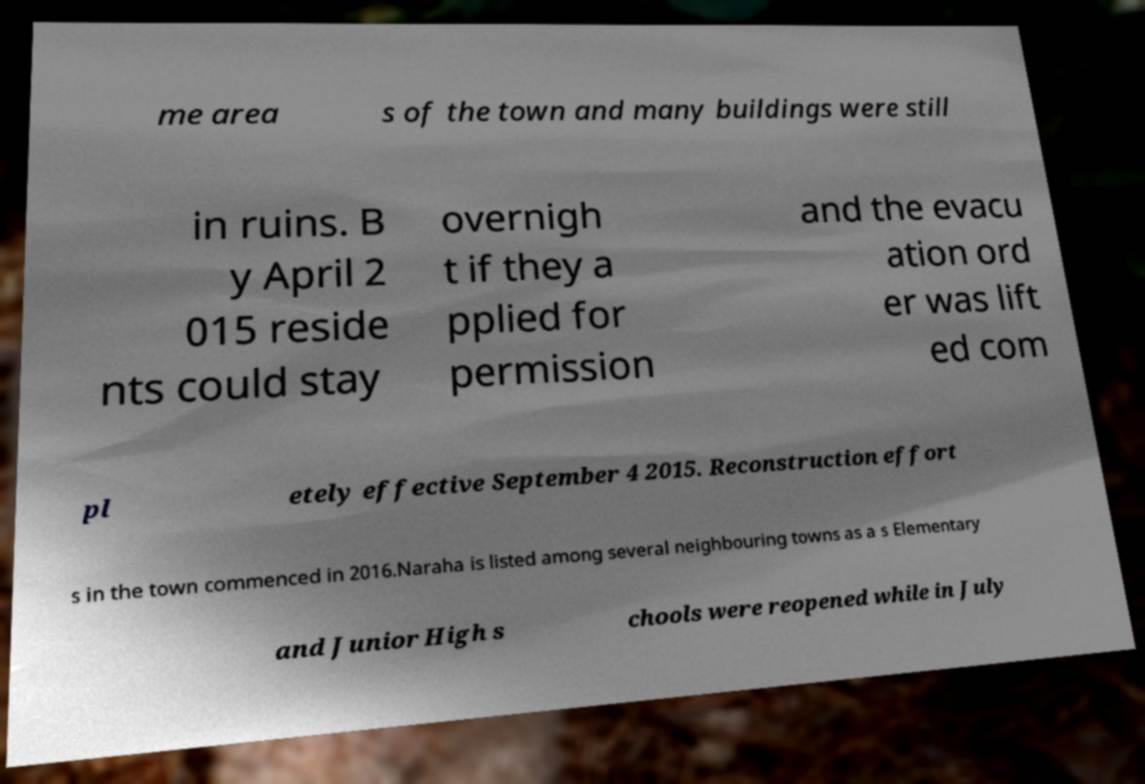I need the written content from this picture converted into text. Can you do that? me area s of the town and many buildings were still in ruins. B y April 2 015 reside nts could stay overnigh t if they a pplied for permission and the evacu ation ord er was lift ed com pl etely effective September 4 2015. Reconstruction effort s in the town commenced in 2016.Naraha is listed among several neighbouring towns as a s Elementary and Junior High s chools were reopened while in July 